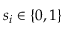Convert formula to latex. <formula><loc_0><loc_0><loc_500><loc_500>s _ { i } \in \{ 0 , 1 \}</formula> 